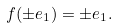<formula> <loc_0><loc_0><loc_500><loc_500>f ( \pm e _ { 1 } ) = \pm e _ { 1 } .</formula> 